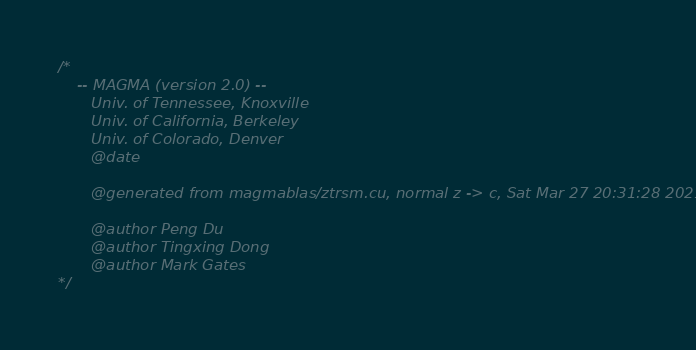<code> <loc_0><loc_0><loc_500><loc_500><_Cuda_>/*
    -- MAGMA (version 2.0) --
       Univ. of Tennessee, Knoxville
       Univ. of California, Berkeley
       Univ. of Colorado, Denver
       @date

       @generated from magmablas/ztrsm.cu, normal z -> c, Sat Mar 27 20:31:28 2021

       @author Peng Du
       @author Tingxing Dong
       @author Mark Gates
*/</code> 